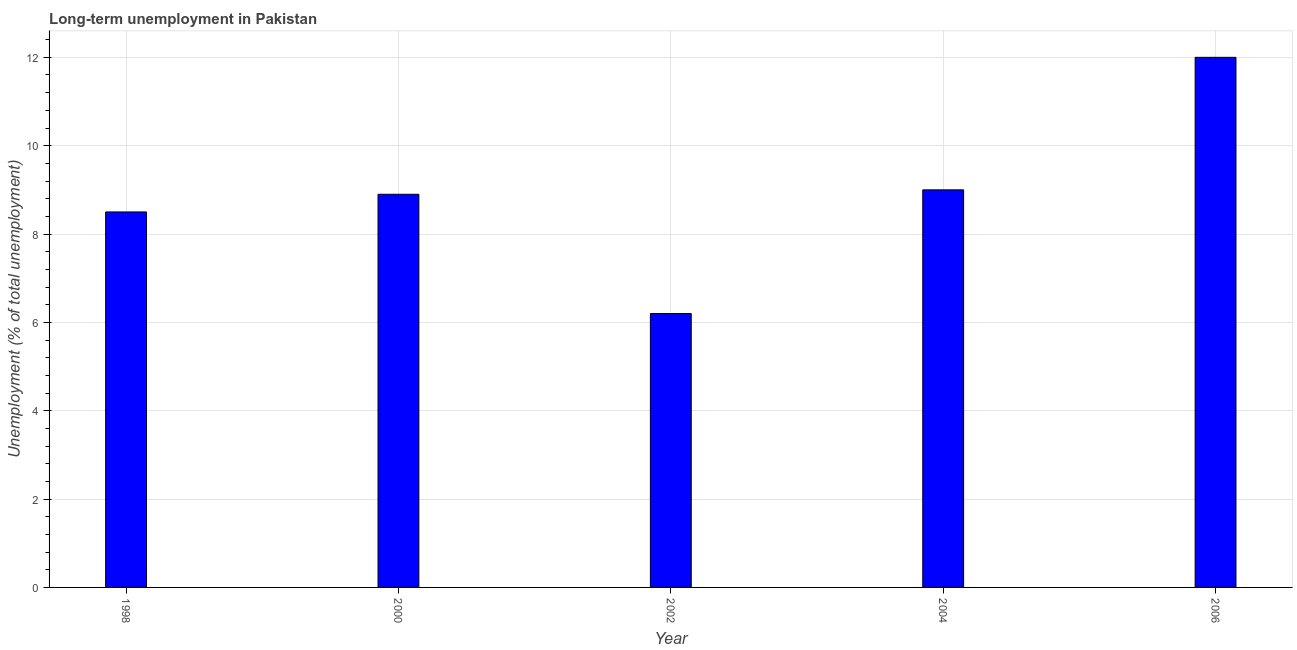What is the title of the graph?
Offer a very short reply. Long-term unemployment in Pakistan. What is the label or title of the Y-axis?
Your answer should be compact. Unemployment (% of total unemployment). Across all years, what is the maximum long-term unemployment?
Your answer should be compact. 12. Across all years, what is the minimum long-term unemployment?
Give a very brief answer. 6.2. In which year was the long-term unemployment maximum?
Provide a succinct answer. 2006. What is the sum of the long-term unemployment?
Your answer should be compact. 44.6. What is the difference between the long-term unemployment in 2002 and 2004?
Your answer should be very brief. -2.8. What is the average long-term unemployment per year?
Your response must be concise. 8.92. What is the median long-term unemployment?
Make the answer very short. 8.9. What is the ratio of the long-term unemployment in 2002 to that in 2006?
Make the answer very short. 0.52. Is the difference between the long-term unemployment in 1998 and 2006 greater than the difference between any two years?
Offer a terse response. No. Are all the bars in the graph horizontal?
Make the answer very short. No. What is the difference between two consecutive major ticks on the Y-axis?
Keep it short and to the point. 2. What is the Unemployment (% of total unemployment) of 2000?
Provide a succinct answer. 8.9. What is the Unemployment (% of total unemployment) in 2002?
Ensure brevity in your answer.  6.2. What is the Unemployment (% of total unemployment) of 2004?
Keep it short and to the point. 9. What is the difference between the Unemployment (% of total unemployment) in 1998 and 2002?
Ensure brevity in your answer.  2.3. What is the difference between the Unemployment (% of total unemployment) in 1998 and 2004?
Your answer should be very brief. -0.5. What is the difference between the Unemployment (% of total unemployment) in 1998 and 2006?
Offer a terse response. -3.5. What is the difference between the Unemployment (% of total unemployment) in 2000 and 2002?
Give a very brief answer. 2.7. What is the difference between the Unemployment (% of total unemployment) in 2002 and 2006?
Make the answer very short. -5.8. What is the difference between the Unemployment (% of total unemployment) in 2004 and 2006?
Ensure brevity in your answer.  -3. What is the ratio of the Unemployment (% of total unemployment) in 1998 to that in 2000?
Make the answer very short. 0.95. What is the ratio of the Unemployment (% of total unemployment) in 1998 to that in 2002?
Your response must be concise. 1.37. What is the ratio of the Unemployment (% of total unemployment) in 1998 to that in 2004?
Offer a terse response. 0.94. What is the ratio of the Unemployment (% of total unemployment) in 1998 to that in 2006?
Provide a short and direct response. 0.71. What is the ratio of the Unemployment (% of total unemployment) in 2000 to that in 2002?
Ensure brevity in your answer.  1.44. What is the ratio of the Unemployment (% of total unemployment) in 2000 to that in 2006?
Your answer should be very brief. 0.74. What is the ratio of the Unemployment (% of total unemployment) in 2002 to that in 2004?
Your answer should be very brief. 0.69. What is the ratio of the Unemployment (% of total unemployment) in 2002 to that in 2006?
Offer a terse response. 0.52. What is the ratio of the Unemployment (% of total unemployment) in 2004 to that in 2006?
Your answer should be very brief. 0.75. 